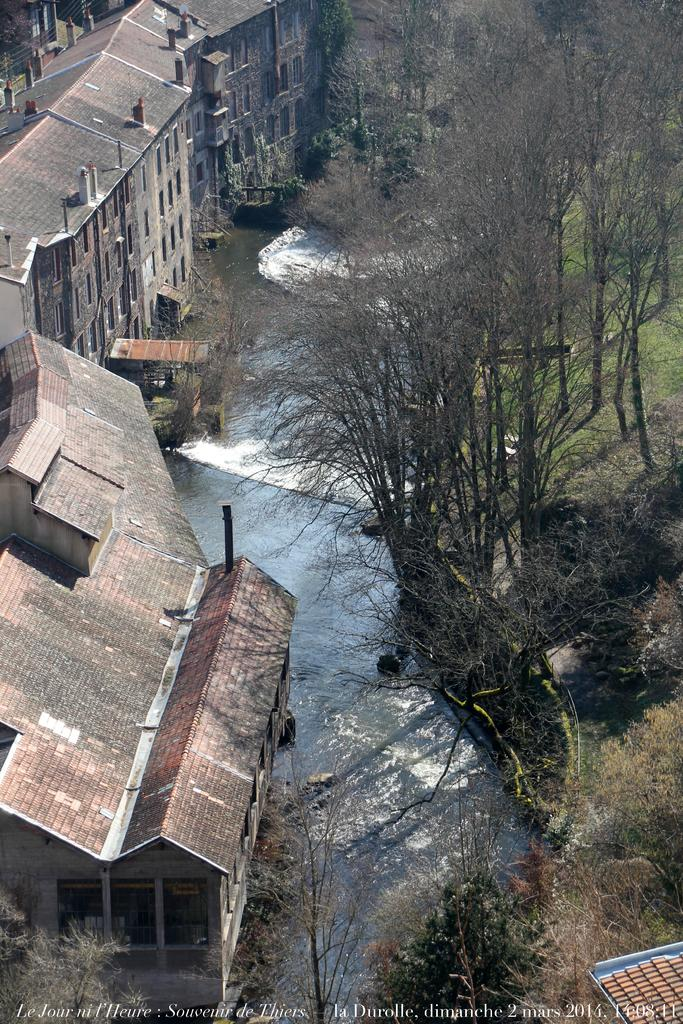What type of structures can be seen in the image? There are buildings in the image. What natural elements are present in the image? There is water, trees, and grass on the ground visible in the image. Where is the text located in the image? The text is at the bottom of the picture. Can you tell me how many hens are standing on the board in the image? There is no hen or board present in the image. What is the weather like in the image? The provided facts do not mention the weather, so we cannot determine the weather from the image. 